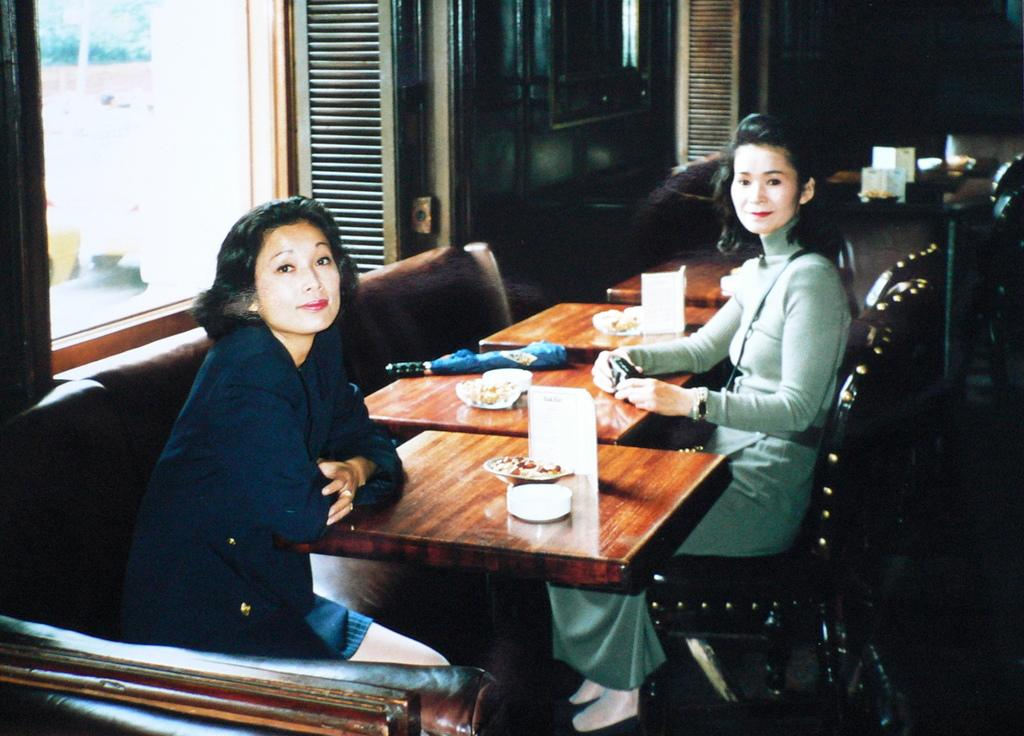How many women are in the image? There are two women in the image. What are the women doing in the image? The women are sitting in chairs. Where are the women located in relation to the table? The women are in front of a table. What can be found on the table? There is food on the table. What can be seen in the background of the image? There is a window and a wall in the background of the image. Can you tell me how many threads are visible in the image? There is no mention of threads in the image, so it is not possible to determine their presence or quantity. 